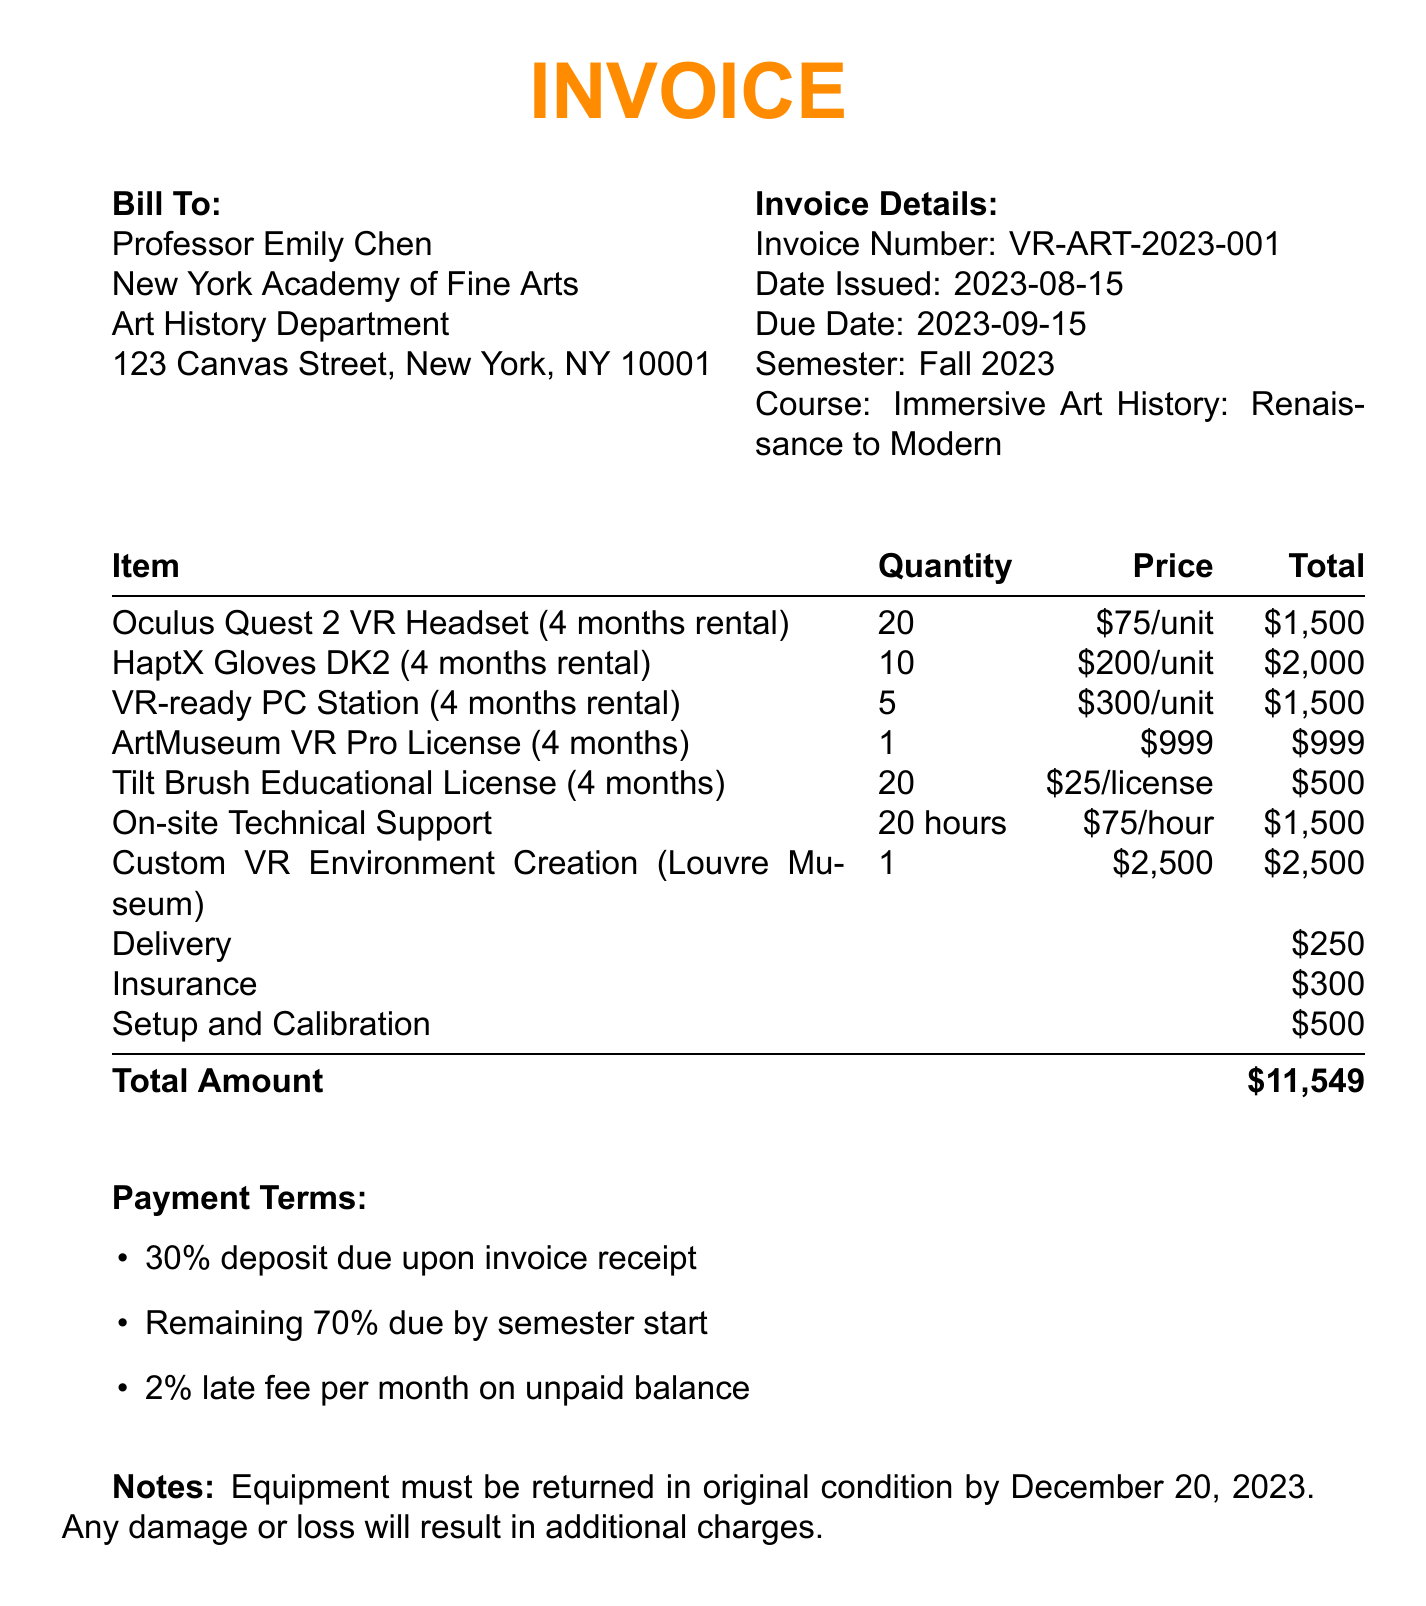What is the invoice number? The invoice number is mentioned in the document and is a unique identifier for this invoice.
Answer: VR-ART-2023-001 Who is the client? The client information section provides the name of the individual responsible for this invoice.
Answer: Professor Emily Chen What is the total amount due? The total amount due is stated clearly in the invoice as the sum of all charges.
Answer: $11,549 How many HaptX Gloves DK2 were rented? The quantity of HaptX Gloves DK2 is provided under the equipment rental section.
Answer: 10 When is the payment due date? The due date is specified in the invoice details and clarifies when payment must be made.
Answer: 2023-09-15 What percentage is the deposit required upon receipt of the invoice? The payment terms detail the deposit percentage required upon receiving the invoice.
Answer: 30% How many Oculus Quest 2 VR Headsets were rented? The quantity of Oculus Quest 2 VR Headsets is detailed in the equipment rental section.
Answer: 20 What type of support service is included? The additional services section lists on-site technical support as a service provided.
Answer: On-site Technical Support What is the charge for the Custom VR Environment Creation? The total cost for creating a custom VR environment is provided in the additional services section.
Answer: $2,500 